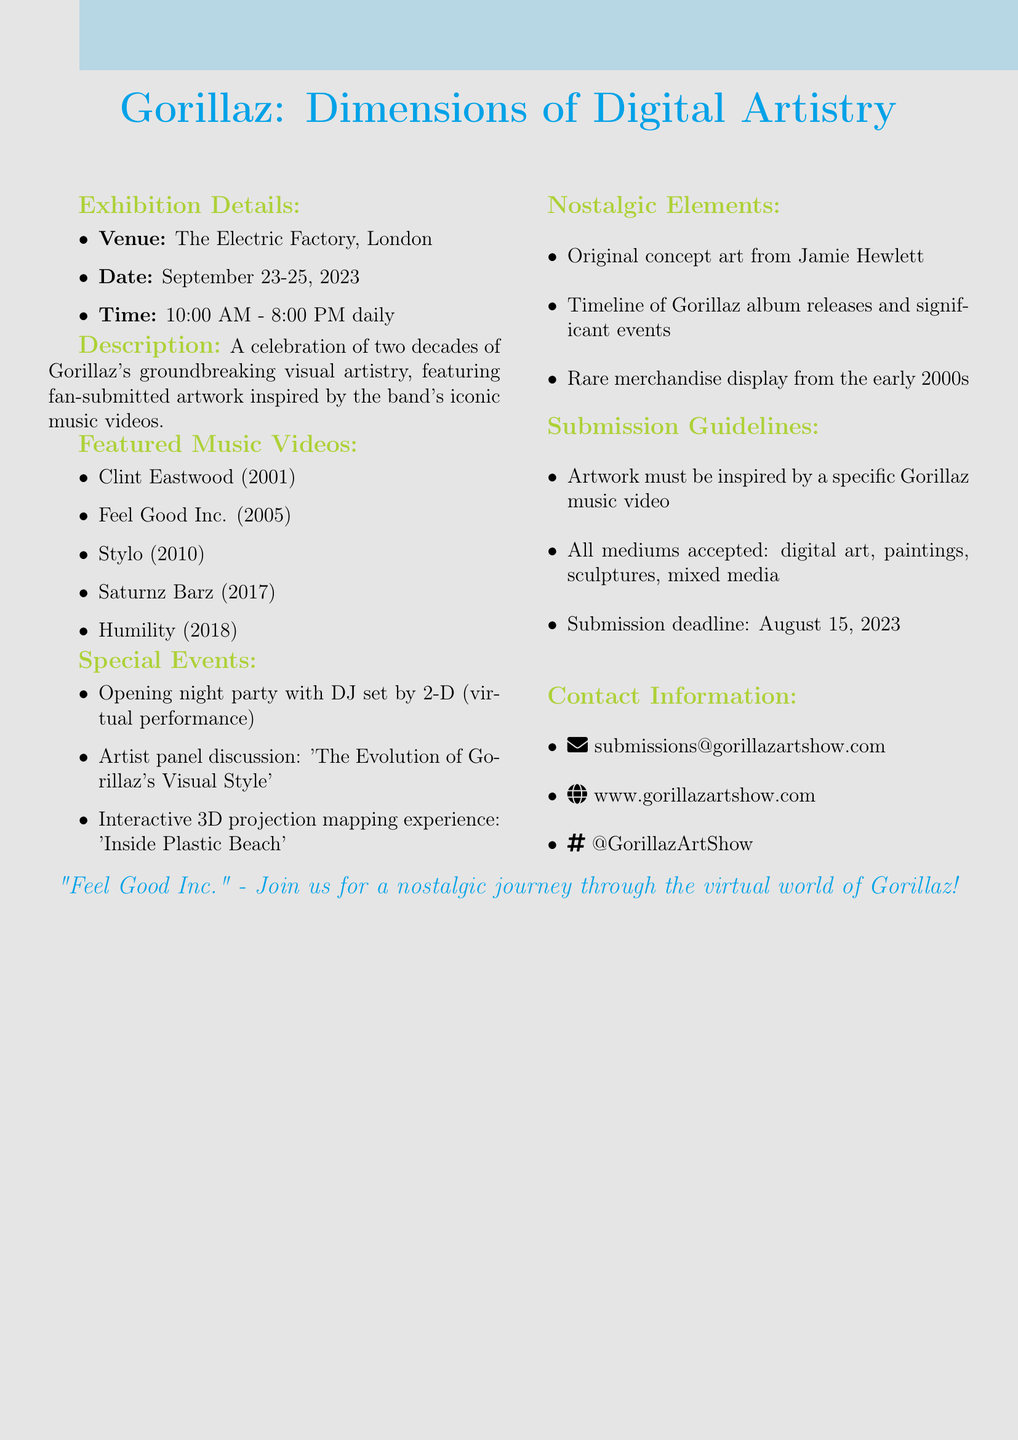What is the title of the exhibition? The title of the exhibition is explicitly stated in the document as "Gorillaz: Dimensions of Digital Artistry."
Answer: Gorillaz: Dimensions of Digital Artistry Where is the venue located? The venue for the exhibition is specified as "The Electric Factory, London."
Answer: The Electric Factory, London What are the exhibition dates? The document lists the exhibition dates as "September 23-25, 2023."
Answer: September 23-25, 2023 Who will be performing at the opening night party? The document mentions a DJ set by 2-D as part of the opening night party.
Answer: 2-D What is the submission deadline for artwork? The submission guidelines specify the deadline for artwork submissions as "August 15, 2023."
Answer: August 15, 2023 Which music video is featured from 2005? The document mentions "Feel Good Inc." as a featured music video from 2005.
Answer: Feel Good Inc What kind of merchandise will be displayed? The document states that there will be a "rare merchandise display from the early 2000s."
Answer: Rare merchandise display from the early 2000s How many hours is the exhibition open each day? The document states that the exhibition is open from 10:00 AM to 8:00 PM, indicating it operates for 10 hours each day.
Answer: 10 hours What type of event is "Inside Plastic Beach"? The event "Inside Plastic Beach" is described as an "interactive 3D projection mapping experience."
Answer: Interactive 3D projection mapping experience 